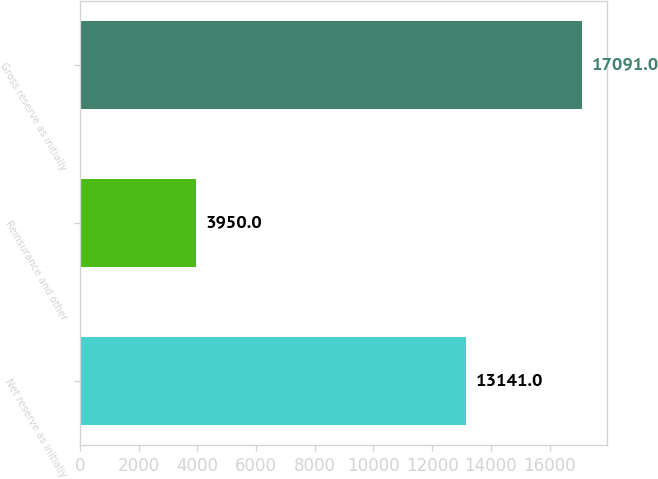Convert chart to OTSL. <chart><loc_0><loc_0><loc_500><loc_500><bar_chart><fcel>Net reserve as initially<fcel>Reinsurance and other<fcel>Gross reserve as initially<nl><fcel>13141<fcel>3950<fcel>17091<nl></chart> 